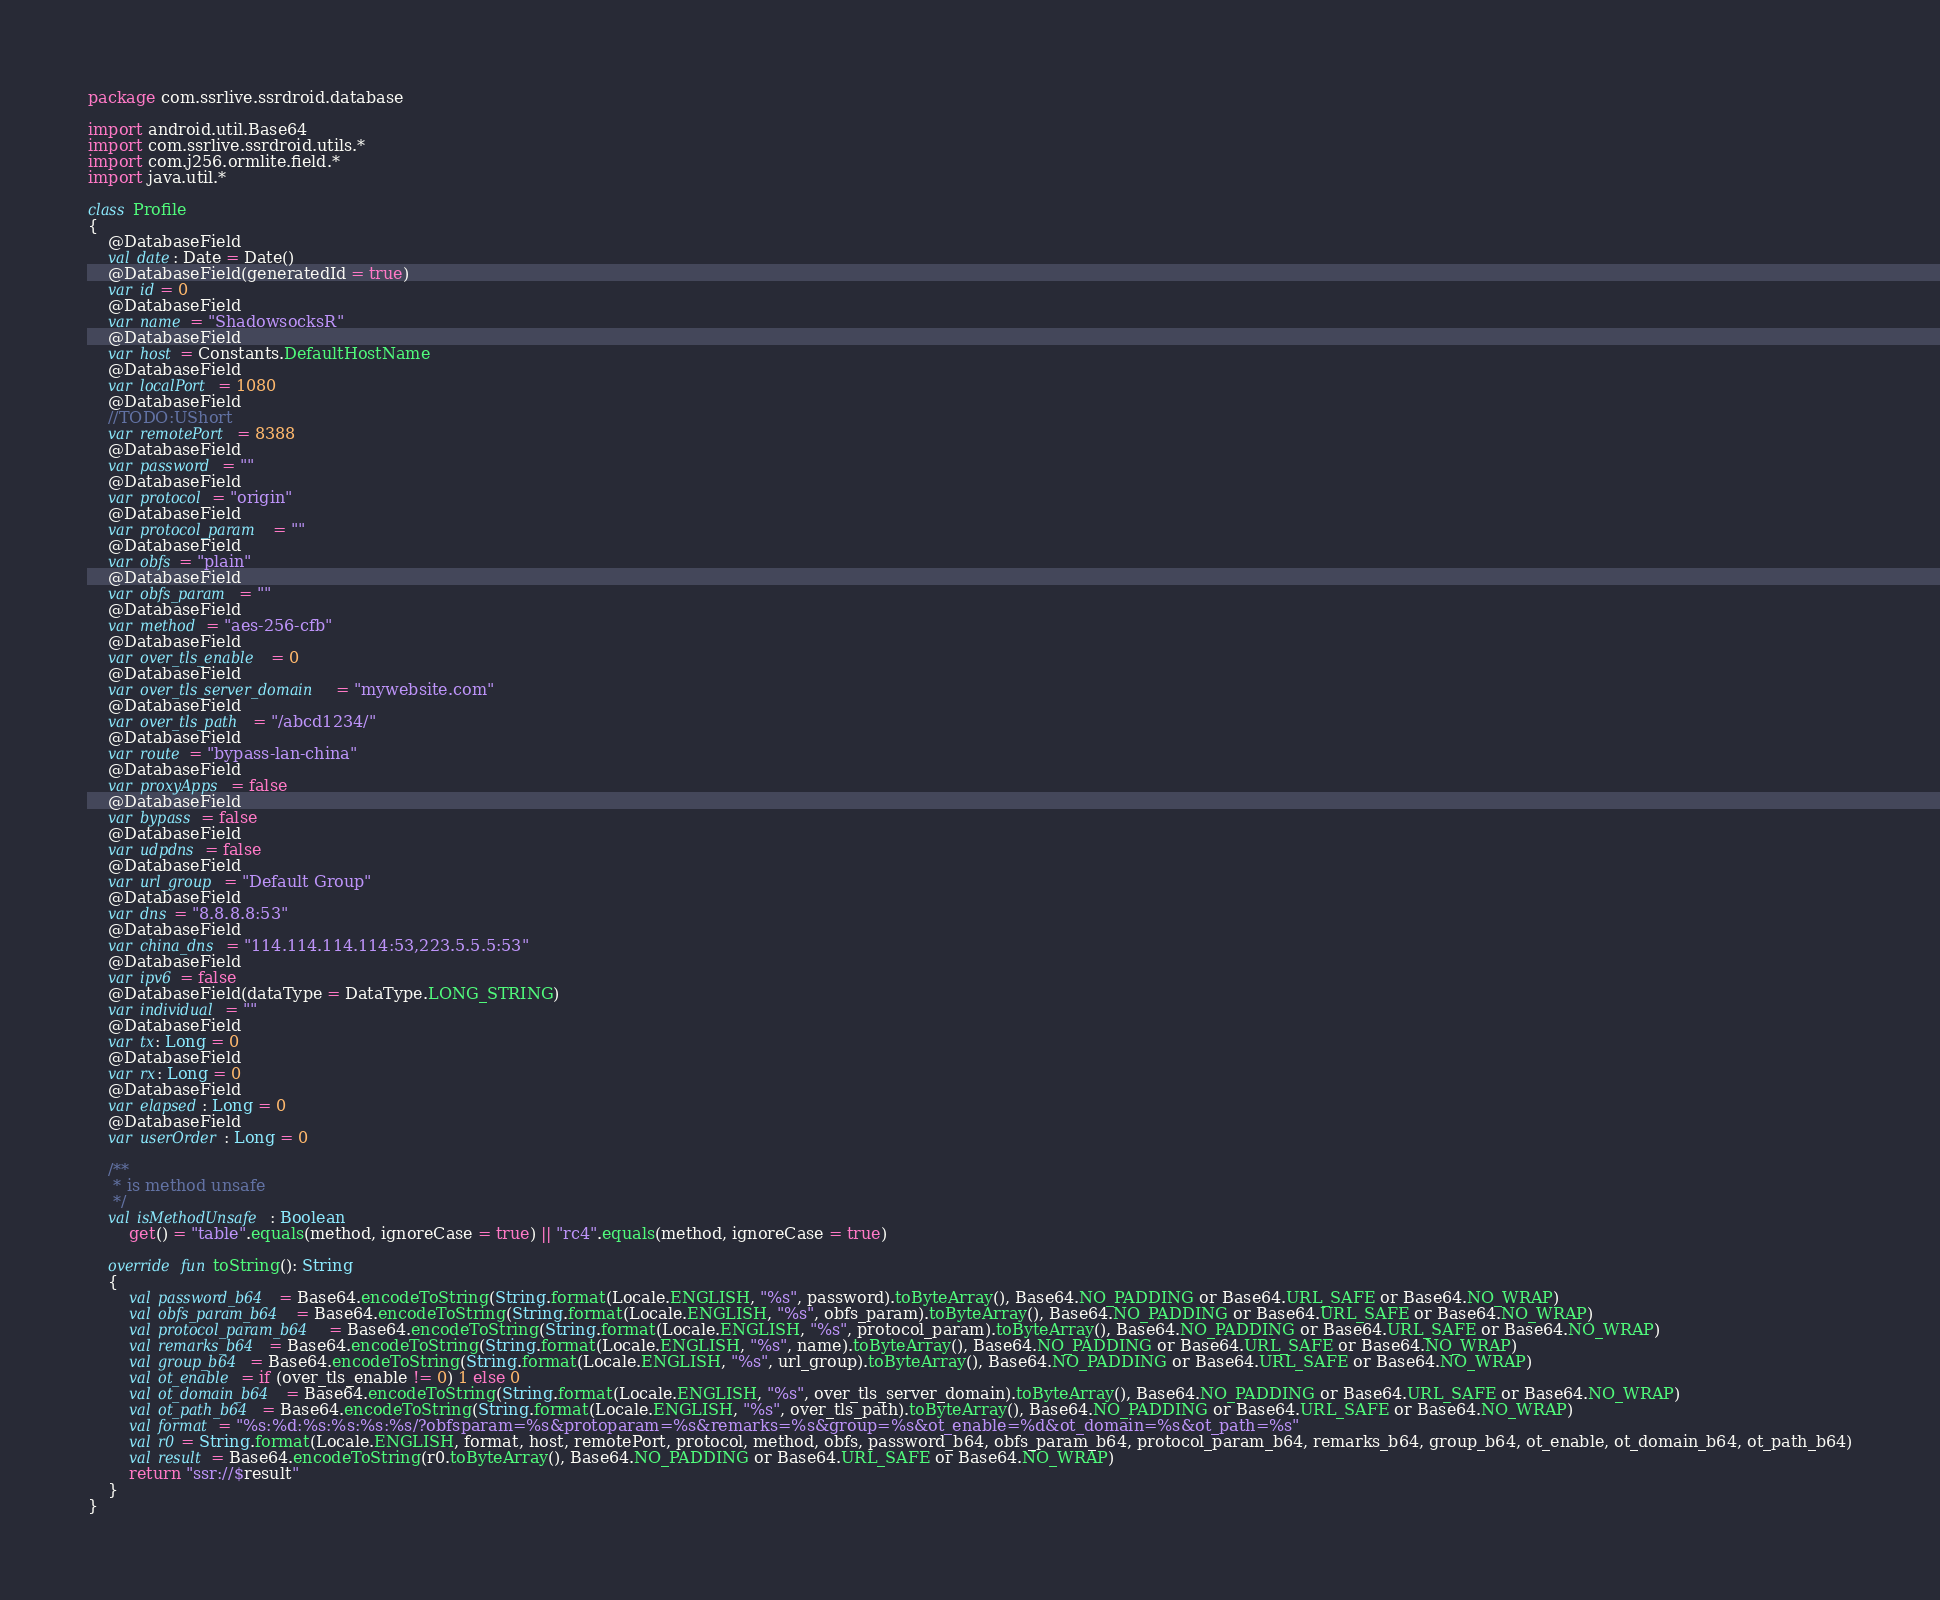<code> <loc_0><loc_0><loc_500><loc_500><_Kotlin_>package com.ssrlive.ssrdroid.database

import android.util.Base64
import com.ssrlive.ssrdroid.utils.*
import com.j256.ormlite.field.*
import java.util.*

class Profile
{
	@DatabaseField
	val date: Date = Date()
	@DatabaseField(generatedId = true)
	var id = 0
	@DatabaseField
	var name = "ShadowsocksR"
	@DatabaseField
	var host = Constants.DefaultHostName
	@DatabaseField
	var localPort = 1080
	@DatabaseField
	//TODO:UShort
	var remotePort = 8388
	@DatabaseField
	var password = ""
	@DatabaseField
	var protocol = "origin"
	@DatabaseField
	var protocol_param = ""
	@DatabaseField
	var obfs = "plain"
	@DatabaseField
	var obfs_param = ""
	@DatabaseField
	var method = "aes-256-cfb"
	@DatabaseField
	var over_tls_enable = 0
	@DatabaseField
	var over_tls_server_domain = "mywebsite.com"
	@DatabaseField
	var over_tls_path = "/abcd1234/"
	@DatabaseField
	var route = "bypass-lan-china"
	@DatabaseField
	var proxyApps = false
	@DatabaseField
	var bypass = false
	@DatabaseField
	var udpdns = false
	@DatabaseField
	var url_group = "Default Group"
	@DatabaseField
	var dns = "8.8.8.8:53"
	@DatabaseField
	var china_dns = "114.114.114.114:53,223.5.5.5:53"
	@DatabaseField
	var ipv6 = false
	@DatabaseField(dataType = DataType.LONG_STRING)
	var individual = ""
	@DatabaseField
	var tx: Long = 0
	@DatabaseField
	var rx: Long = 0
	@DatabaseField
	var elapsed: Long = 0
	@DatabaseField
	var userOrder: Long = 0

	/**
	 * is method unsafe
	 */
	val isMethodUnsafe: Boolean
		get() = "table".equals(method, ignoreCase = true) || "rc4".equals(method, ignoreCase = true)

	override fun toString(): String
	{
		val password_b64 = Base64.encodeToString(String.format(Locale.ENGLISH, "%s", password).toByteArray(), Base64.NO_PADDING or Base64.URL_SAFE or Base64.NO_WRAP)
		val obfs_param_b64 = Base64.encodeToString(String.format(Locale.ENGLISH, "%s", obfs_param).toByteArray(), Base64.NO_PADDING or Base64.URL_SAFE or Base64.NO_WRAP)
		val protocol_param_b64 = Base64.encodeToString(String.format(Locale.ENGLISH, "%s", protocol_param).toByteArray(), Base64.NO_PADDING or Base64.URL_SAFE or Base64.NO_WRAP)
		val remarks_b64 = Base64.encodeToString(String.format(Locale.ENGLISH, "%s", name).toByteArray(), Base64.NO_PADDING or Base64.URL_SAFE or Base64.NO_WRAP)
		val group_b64 = Base64.encodeToString(String.format(Locale.ENGLISH, "%s", url_group).toByteArray(), Base64.NO_PADDING or Base64.URL_SAFE or Base64.NO_WRAP)
		val ot_enable = if (over_tls_enable != 0) 1 else 0
		val ot_domain_b64 = Base64.encodeToString(String.format(Locale.ENGLISH, "%s", over_tls_server_domain).toByteArray(), Base64.NO_PADDING or Base64.URL_SAFE or Base64.NO_WRAP)
		val ot_path_b64 = Base64.encodeToString(String.format(Locale.ENGLISH, "%s", over_tls_path).toByteArray(), Base64.NO_PADDING or Base64.URL_SAFE or Base64.NO_WRAP)
		val format = "%s:%d:%s:%s:%s:%s/?obfsparam=%s&protoparam=%s&remarks=%s&group=%s&ot_enable=%d&ot_domain=%s&ot_path=%s"
		val r0 = String.format(Locale.ENGLISH, format, host, remotePort, protocol, method, obfs, password_b64, obfs_param_b64, protocol_param_b64, remarks_b64, group_b64, ot_enable, ot_domain_b64, ot_path_b64)
		val result = Base64.encodeToString(r0.toByteArray(), Base64.NO_PADDING or Base64.URL_SAFE or Base64.NO_WRAP)
		return "ssr://$result"
	}
}
</code> 